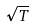Convert formula to latex. <formula><loc_0><loc_0><loc_500><loc_500>\sqrt { T }</formula> 